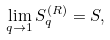Convert formula to latex. <formula><loc_0><loc_0><loc_500><loc_500>\lim _ { q \to 1 } S _ { q } ^ { ( R ) } = S ,</formula> 